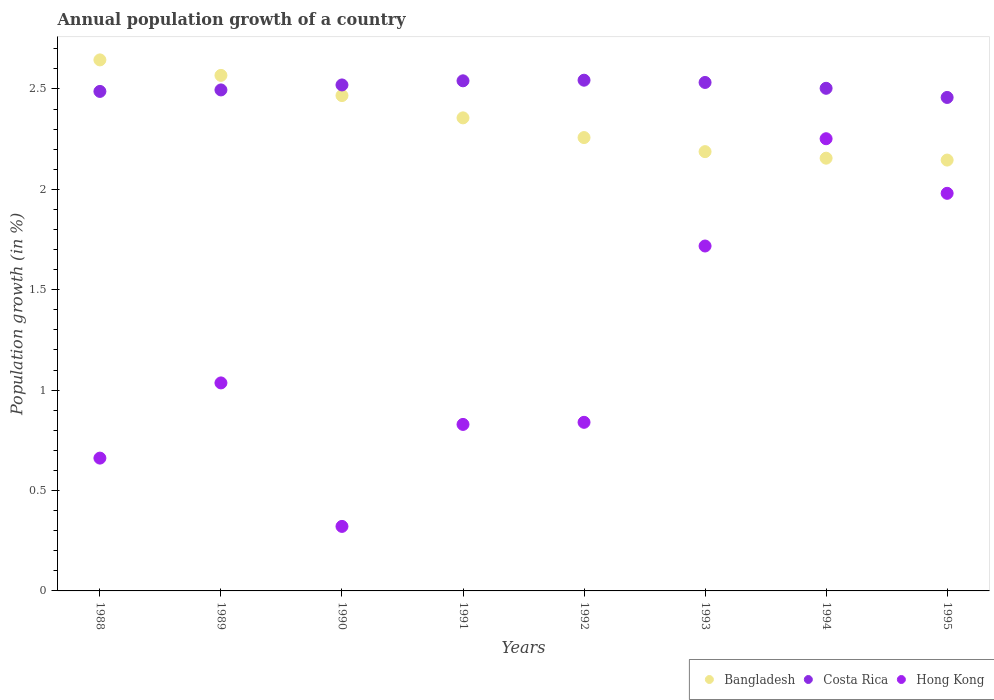How many different coloured dotlines are there?
Make the answer very short. 3. What is the annual population growth in Hong Kong in 1990?
Your answer should be very brief. 0.32. Across all years, what is the maximum annual population growth in Bangladesh?
Provide a succinct answer. 2.64. Across all years, what is the minimum annual population growth in Costa Rica?
Offer a very short reply. 2.46. In which year was the annual population growth in Bangladesh maximum?
Provide a succinct answer. 1988. What is the total annual population growth in Costa Rica in the graph?
Your answer should be very brief. 20.08. What is the difference between the annual population growth in Bangladesh in 1990 and that in 1992?
Your answer should be compact. 0.21. What is the difference between the annual population growth in Hong Kong in 1993 and the annual population growth in Costa Rica in 1995?
Offer a terse response. -0.74. What is the average annual population growth in Bangladesh per year?
Keep it short and to the point. 2.35. In the year 1988, what is the difference between the annual population growth in Hong Kong and annual population growth in Costa Rica?
Offer a terse response. -1.83. What is the ratio of the annual population growth in Bangladesh in 1988 to that in 1990?
Give a very brief answer. 1.07. Is the annual population growth in Hong Kong in 1990 less than that in 1993?
Provide a short and direct response. Yes. Is the difference between the annual population growth in Hong Kong in 1992 and 1995 greater than the difference between the annual population growth in Costa Rica in 1992 and 1995?
Your answer should be compact. No. What is the difference between the highest and the second highest annual population growth in Bangladesh?
Keep it short and to the point. 0.08. What is the difference between the highest and the lowest annual population growth in Hong Kong?
Provide a succinct answer. 1.93. In how many years, is the annual population growth in Bangladesh greater than the average annual population growth in Bangladesh taken over all years?
Offer a very short reply. 4. Is it the case that in every year, the sum of the annual population growth in Costa Rica and annual population growth in Bangladesh  is greater than the annual population growth in Hong Kong?
Your answer should be very brief. Yes. Is the annual population growth in Hong Kong strictly less than the annual population growth in Costa Rica over the years?
Your response must be concise. Yes. How many years are there in the graph?
Offer a terse response. 8. Does the graph contain any zero values?
Your answer should be compact. No. Does the graph contain grids?
Your answer should be very brief. No. Where does the legend appear in the graph?
Your answer should be compact. Bottom right. What is the title of the graph?
Ensure brevity in your answer.  Annual population growth of a country. What is the label or title of the X-axis?
Your answer should be compact. Years. What is the label or title of the Y-axis?
Offer a very short reply. Population growth (in %). What is the Population growth (in %) in Bangladesh in 1988?
Your answer should be very brief. 2.64. What is the Population growth (in %) in Costa Rica in 1988?
Offer a terse response. 2.49. What is the Population growth (in %) of Hong Kong in 1988?
Provide a short and direct response. 0.66. What is the Population growth (in %) of Bangladesh in 1989?
Give a very brief answer. 2.57. What is the Population growth (in %) of Costa Rica in 1989?
Provide a short and direct response. 2.5. What is the Population growth (in %) of Hong Kong in 1989?
Make the answer very short. 1.04. What is the Population growth (in %) in Bangladesh in 1990?
Make the answer very short. 2.47. What is the Population growth (in %) of Costa Rica in 1990?
Offer a very short reply. 2.52. What is the Population growth (in %) of Hong Kong in 1990?
Provide a short and direct response. 0.32. What is the Population growth (in %) of Bangladesh in 1991?
Provide a succinct answer. 2.36. What is the Population growth (in %) of Costa Rica in 1991?
Keep it short and to the point. 2.54. What is the Population growth (in %) in Hong Kong in 1991?
Offer a very short reply. 0.83. What is the Population growth (in %) of Bangladesh in 1992?
Ensure brevity in your answer.  2.26. What is the Population growth (in %) in Costa Rica in 1992?
Offer a very short reply. 2.54. What is the Population growth (in %) of Hong Kong in 1992?
Make the answer very short. 0.84. What is the Population growth (in %) in Bangladesh in 1993?
Provide a short and direct response. 2.19. What is the Population growth (in %) of Costa Rica in 1993?
Offer a very short reply. 2.53. What is the Population growth (in %) in Hong Kong in 1993?
Your answer should be very brief. 1.72. What is the Population growth (in %) in Bangladesh in 1994?
Provide a succinct answer. 2.16. What is the Population growth (in %) in Costa Rica in 1994?
Ensure brevity in your answer.  2.5. What is the Population growth (in %) of Hong Kong in 1994?
Give a very brief answer. 2.25. What is the Population growth (in %) in Bangladesh in 1995?
Offer a very short reply. 2.15. What is the Population growth (in %) in Costa Rica in 1995?
Give a very brief answer. 2.46. What is the Population growth (in %) of Hong Kong in 1995?
Offer a terse response. 1.98. Across all years, what is the maximum Population growth (in %) of Bangladesh?
Your response must be concise. 2.64. Across all years, what is the maximum Population growth (in %) of Costa Rica?
Provide a short and direct response. 2.54. Across all years, what is the maximum Population growth (in %) of Hong Kong?
Make the answer very short. 2.25. Across all years, what is the minimum Population growth (in %) of Bangladesh?
Provide a succinct answer. 2.15. Across all years, what is the minimum Population growth (in %) of Costa Rica?
Provide a succinct answer. 2.46. Across all years, what is the minimum Population growth (in %) of Hong Kong?
Give a very brief answer. 0.32. What is the total Population growth (in %) in Bangladesh in the graph?
Your answer should be very brief. 18.78. What is the total Population growth (in %) in Costa Rica in the graph?
Make the answer very short. 20.08. What is the total Population growth (in %) in Hong Kong in the graph?
Your response must be concise. 9.64. What is the difference between the Population growth (in %) in Bangladesh in 1988 and that in 1989?
Offer a terse response. 0.08. What is the difference between the Population growth (in %) of Costa Rica in 1988 and that in 1989?
Give a very brief answer. -0.01. What is the difference between the Population growth (in %) in Hong Kong in 1988 and that in 1989?
Make the answer very short. -0.37. What is the difference between the Population growth (in %) of Bangladesh in 1988 and that in 1990?
Your answer should be compact. 0.18. What is the difference between the Population growth (in %) of Costa Rica in 1988 and that in 1990?
Provide a short and direct response. -0.03. What is the difference between the Population growth (in %) in Hong Kong in 1988 and that in 1990?
Provide a short and direct response. 0.34. What is the difference between the Population growth (in %) of Bangladesh in 1988 and that in 1991?
Offer a very short reply. 0.29. What is the difference between the Population growth (in %) in Costa Rica in 1988 and that in 1991?
Provide a succinct answer. -0.05. What is the difference between the Population growth (in %) in Hong Kong in 1988 and that in 1991?
Ensure brevity in your answer.  -0.17. What is the difference between the Population growth (in %) in Bangladesh in 1988 and that in 1992?
Provide a succinct answer. 0.39. What is the difference between the Population growth (in %) in Costa Rica in 1988 and that in 1992?
Offer a terse response. -0.06. What is the difference between the Population growth (in %) of Hong Kong in 1988 and that in 1992?
Provide a succinct answer. -0.18. What is the difference between the Population growth (in %) in Bangladesh in 1988 and that in 1993?
Your response must be concise. 0.46. What is the difference between the Population growth (in %) in Costa Rica in 1988 and that in 1993?
Make the answer very short. -0.04. What is the difference between the Population growth (in %) of Hong Kong in 1988 and that in 1993?
Give a very brief answer. -1.06. What is the difference between the Population growth (in %) in Bangladesh in 1988 and that in 1994?
Provide a short and direct response. 0.49. What is the difference between the Population growth (in %) of Costa Rica in 1988 and that in 1994?
Offer a very short reply. -0.02. What is the difference between the Population growth (in %) in Hong Kong in 1988 and that in 1994?
Keep it short and to the point. -1.59. What is the difference between the Population growth (in %) of Bangladesh in 1988 and that in 1995?
Provide a succinct answer. 0.5. What is the difference between the Population growth (in %) of Costa Rica in 1988 and that in 1995?
Keep it short and to the point. 0.03. What is the difference between the Population growth (in %) in Hong Kong in 1988 and that in 1995?
Your answer should be compact. -1.32. What is the difference between the Population growth (in %) of Bangladesh in 1989 and that in 1990?
Offer a terse response. 0.1. What is the difference between the Population growth (in %) of Costa Rica in 1989 and that in 1990?
Provide a succinct answer. -0.02. What is the difference between the Population growth (in %) in Hong Kong in 1989 and that in 1990?
Your answer should be very brief. 0.71. What is the difference between the Population growth (in %) of Bangladesh in 1989 and that in 1991?
Provide a short and direct response. 0.21. What is the difference between the Population growth (in %) of Costa Rica in 1989 and that in 1991?
Offer a very short reply. -0.05. What is the difference between the Population growth (in %) in Hong Kong in 1989 and that in 1991?
Your response must be concise. 0.21. What is the difference between the Population growth (in %) of Bangladesh in 1989 and that in 1992?
Keep it short and to the point. 0.31. What is the difference between the Population growth (in %) of Costa Rica in 1989 and that in 1992?
Ensure brevity in your answer.  -0.05. What is the difference between the Population growth (in %) in Hong Kong in 1989 and that in 1992?
Your response must be concise. 0.2. What is the difference between the Population growth (in %) in Bangladesh in 1989 and that in 1993?
Ensure brevity in your answer.  0.38. What is the difference between the Population growth (in %) in Costa Rica in 1989 and that in 1993?
Provide a short and direct response. -0.04. What is the difference between the Population growth (in %) of Hong Kong in 1989 and that in 1993?
Ensure brevity in your answer.  -0.68. What is the difference between the Population growth (in %) of Bangladesh in 1989 and that in 1994?
Ensure brevity in your answer.  0.41. What is the difference between the Population growth (in %) of Costa Rica in 1989 and that in 1994?
Your response must be concise. -0.01. What is the difference between the Population growth (in %) of Hong Kong in 1989 and that in 1994?
Offer a very short reply. -1.22. What is the difference between the Population growth (in %) in Bangladesh in 1989 and that in 1995?
Give a very brief answer. 0.42. What is the difference between the Population growth (in %) in Costa Rica in 1989 and that in 1995?
Offer a very short reply. 0.04. What is the difference between the Population growth (in %) of Hong Kong in 1989 and that in 1995?
Offer a terse response. -0.94. What is the difference between the Population growth (in %) of Bangladesh in 1990 and that in 1991?
Ensure brevity in your answer.  0.11. What is the difference between the Population growth (in %) in Costa Rica in 1990 and that in 1991?
Keep it short and to the point. -0.02. What is the difference between the Population growth (in %) in Hong Kong in 1990 and that in 1991?
Make the answer very short. -0.51. What is the difference between the Population growth (in %) in Bangladesh in 1990 and that in 1992?
Ensure brevity in your answer.  0.21. What is the difference between the Population growth (in %) of Costa Rica in 1990 and that in 1992?
Keep it short and to the point. -0.02. What is the difference between the Population growth (in %) of Hong Kong in 1990 and that in 1992?
Ensure brevity in your answer.  -0.52. What is the difference between the Population growth (in %) of Bangladesh in 1990 and that in 1993?
Offer a terse response. 0.28. What is the difference between the Population growth (in %) in Costa Rica in 1990 and that in 1993?
Offer a terse response. -0.01. What is the difference between the Population growth (in %) in Hong Kong in 1990 and that in 1993?
Offer a terse response. -1.4. What is the difference between the Population growth (in %) in Bangladesh in 1990 and that in 1994?
Provide a succinct answer. 0.31. What is the difference between the Population growth (in %) in Costa Rica in 1990 and that in 1994?
Your answer should be compact. 0.02. What is the difference between the Population growth (in %) of Hong Kong in 1990 and that in 1994?
Your answer should be very brief. -1.93. What is the difference between the Population growth (in %) in Bangladesh in 1990 and that in 1995?
Offer a terse response. 0.32. What is the difference between the Population growth (in %) of Costa Rica in 1990 and that in 1995?
Offer a very short reply. 0.06. What is the difference between the Population growth (in %) of Hong Kong in 1990 and that in 1995?
Give a very brief answer. -1.66. What is the difference between the Population growth (in %) of Bangladesh in 1991 and that in 1992?
Keep it short and to the point. 0.1. What is the difference between the Population growth (in %) of Costa Rica in 1991 and that in 1992?
Offer a terse response. -0. What is the difference between the Population growth (in %) in Hong Kong in 1991 and that in 1992?
Offer a very short reply. -0.01. What is the difference between the Population growth (in %) in Bangladesh in 1991 and that in 1993?
Offer a terse response. 0.17. What is the difference between the Population growth (in %) of Costa Rica in 1991 and that in 1993?
Make the answer very short. 0.01. What is the difference between the Population growth (in %) of Hong Kong in 1991 and that in 1993?
Keep it short and to the point. -0.89. What is the difference between the Population growth (in %) of Bangladesh in 1991 and that in 1994?
Keep it short and to the point. 0.2. What is the difference between the Population growth (in %) in Costa Rica in 1991 and that in 1994?
Your response must be concise. 0.04. What is the difference between the Population growth (in %) in Hong Kong in 1991 and that in 1994?
Ensure brevity in your answer.  -1.42. What is the difference between the Population growth (in %) in Bangladesh in 1991 and that in 1995?
Provide a succinct answer. 0.21. What is the difference between the Population growth (in %) of Costa Rica in 1991 and that in 1995?
Your answer should be compact. 0.08. What is the difference between the Population growth (in %) of Hong Kong in 1991 and that in 1995?
Offer a terse response. -1.15. What is the difference between the Population growth (in %) of Bangladesh in 1992 and that in 1993?
Make the answer very short. 0.07. What is the difference between the Population growth (in %) in Costa Rica in 1992 and that in 1993?
Offer a terse response. 0.01. What is the difference between the Population growth (in %) in Hong Kong in 1992 and that in 1993?
Your response must be concise. -0.88. What is the difference between the Population growth (in %) of Bangladesh in 1992 and that in 1994?
Ensure brevity in your answer.  0.1. What is the difference between the Population growth (in %) of Costa Rica in 1992 and that in 1994?
Offer a terse response. 0.04. What is the difference between the Population growth (in %) in Hong Kong in 1992 and that in 1994?
Provide a short and direct response. -1.41. What is the difference between the Population growth (in %) of Bangladesh in 1992 and that in 1995?
Offer a terse response. 0.11. What is the difference between the Population growth (in %) of Costa Rica in 1992 and that in 1995?
Your answer should be very brief. 0.09. What is the difference between the Population growth (in %) in Hong Kong in 1992 and that in 1995?
Your answer should be very brief. -1.14. What is the difference between the Population growth (in %) in Bangladesh in 1993 and that in 1994?
Offer a terse response. 0.03. What is the difference between the Population growth (in %) in Costa Rica in 1993 and that in 1994?
Provide a short and direct response. 0.03. What is the difference between the Population growth (in %) of Hong Kong in 1993 and that in 1994?
Provide a short and direct response. -0.53. What is the difference between the Population growth (in %) in Bangladesh in 1993 and that in 1995?
Ensure brevity in your answer.  0.04. What is the difference between the Population growth (in %) in Costa Rica in 1993 and that in 1995?
Give a very brief answer. 0.07. What is the difference between the Population growth (in %) of Hong Kong in 1993 and that in 1995?
Your answer should be compact. -0.26. What is the difference between the Population growth (in %) of Bangladesh in 1994 and that in 1995?
Your response must be concise. 0.01. What is the difference between the Population growth (in %) in Costa Rica in 1994 and that in 1995?
Offer a terse response. 0.05. What is the difference between the Population growth (in %) in Hong Kong in 1994 and that in 1995?
Your answer should be compact. 0.27. What is the difference between the Population growth (in %) of Bangladesh in 1988 and the Population growth (in %) of Costa Rica in 1989?
Provide a succinct answer. 0.15. What is the difference between the Population growth (in %) in Bangladesh in 1988 and the Population growth (in %) in Hong Kong in 1989?
Provide a succinct answer. 1.61. What is the difference between the Population growth (in %) in Costa Rica in 1988 and the Population growth (in %) in Hong Kong in 1989?
Offer a very short reply. 1.45. What is the difference between the Population growth (in %) of Bangladesh in 1988 and the Population growth (in %) of Costa Rica in 1990?
Give a very brief answer. 0.12. What is the difference between the Population growth (in %) of Bangladesh in 1988 and the Population growth (in %) of Hong Kong in 1990?
Ensure brevity in your answer.  2.32. What is the difference between the Population growth (in %) of Costa Rica in 1988 and the Population growth (in %) of Hong Kong in 1990?
Offer a very short reply. 2.17. What is the difference between the Population growth (in %) in Bangladesh in 1988 and the Population growth (in %) in Costa Rica in 1991?
Offer a very short reply. 0.1. What is the difference between the Population growth (in %) of Bangladesh in 1988 and the Population growth (in %) of Hong Kong in 1991?
Ensure brevity in your answer.  1.82. What is the difference between the Population growth (in %) in Costa Rica in 1988 and the Population growth (in %) in Hong Kong in 1991?
Make the answer very short. 1.66. What is the difference between the Population growth (in %) in Bangladesh in 1988 and the Population growth (in %) in Costa Rica in 1992?
Make the answer very short. 0.1. What is the difference between the Population growth (in %) of Bangladesh in 1988 and the Population growth (in %) of Hong Kong in 1992?
Offer a terse response. 1.8. What is the difference between the Population growth (in %) of Costa Rica in 1988 and the Population growth (in %) of Hong Kong in 1992?
Keep it short and to the point. 1.65. What is the difference between the Population growth (in %) of Bangladesh in 1988 and the Population growth (in %) of Costa Rica in 1993?
Keep it short and to the point. 0.11. What is the difference between the Population growth (in %) of Bangladesh in 1988 and the Population growth (in %) of Hong Kong in 1993?
Make the answer very short. 0.93. What is the difference between the Population growth (in %) of Costa Rica in 1988 and the Population growth (in %) of Hong Kong in 1993?
Keep it short and to the point. 0.77. What is the difference between the Population growth (in %) of Bangladesh in 1988 and the Population growth (in %) of Costa Rica in 1994?
Give a very brief answer. 0.14. What is the difference between the Population growth (in %) of Bangladesh in 1988 and the Population growth (in %) of Hong Kong in 1994?
Provide a short and direct response. 0.39. What is the difference between the Population growth (in %) of Costa Rica in 1988 and the Population growth (in %) of Hong Kong in 1994?
Make the answer very short. 0.24. What is the difference between the Population growth (in %) of Bangladesh in 1988 and the Population growth (in %) of Costa Rica in 1995?
Offer a very short reply. 0.19. What is the difference between the Population growth (in %) in Bangladesh in 1988 and the Population growth (in %) in Hong Kong in 1995?
Keep it short and to the point. 0.66. What is the difference between the Population growth (in %) of Costa Rica in 1988 and the Population growth (in %) of Hong Kong in 1995?
Provide a short and direct response. 0.51. What is the difference between the Population growth (in %) in Bangladesh in 1989 and the Population growth (in %) in Costa Rica in 1990?
Give a very brief answer. 0.05. What is the difference between the Population growth (in %) in Bangladesh in 1989 and the Population growth (in %) in Hong Kong in 1990?
Provide a short and direct response. 2.25. What is the difference between the Population growth (in %) in Costa Rica in 1989 and the Population growth (in %) in Hong Kong in 1990?
Offer a terse response. 2.17. What is the difference between the Population growth (in %) of Bangladesh in 1989 and the Population growth (in %) of Costa Rica in 1991?
Your response must be concise. 0.03. What is the difference between the Population growth (in %) of Bangladesh in 1989 and the Population growth (in %) of Hong Kong in 1991?
Give a very brief answer. 1.74. What is the difference between the Population growth (in %) in Costa Rica in 1989 and the Population growth (in %) in Hong Kong in 1991?
Offer a terse response. 1.67. What is the difference between the Population growth (in %) of Bangladesh in 1989 and the Population growth (in %) of Costa Rica in 1992?
Provide a succinct answer. 0.02. What is the difference between the Population growth (in %) of Bangladesh in 1989 and the Population growth (in %) of Hong Kong in 1992?
Offer a very short reply. 1.73. What is the difference between the Population growth (in %) in Costa Rica in 1989 and the Population growth (in %) in Hong Kong in 1992?
Keep it short and to the point. 1.66. What is the difference between the Population growth (in %) of Bangladesh in 1989 and the Population growth (in %) of Costa Rica in 1993?
Your answer should be very brief. 0.04. What is the difference between the Population growth (in %) in Bangladesh in 1989 and the Population growth (in %) in Hong Kong in 1993?
Offer a very short reply. 0.85. What is the difference between the Population growth (in %) of Costa Rica in 1989 and the Population growth (in %) of Hong Kong in 1993?
Provide a succinct answer. 0.78. What is the difference between the Population growth (in %) in Bangladesh in 1989 and the Population growth (in %) in Costa Rica in 1994?
Offer a terse response. 0.06. What is the difference between the Population growth (in %) in Bangladesh in 1989 and the Population growth (in %) in Hong Kong in 1994?
Provide a short and direct response. 0.32. What is the difference between the Population growth (in %) of Costa Rica in 1989 and the Population growth (in %) of Hong Kong in 1994?
Keep it short and to the point. 0.24. What is the difference between the Population growth (in %) of Bangladesh in 1989 and the Population growth (in %) of Costa Rica in 1995?
Provide a succinct answer. 0.11. What is the difference between the Population growth (in %) of Bangladesh in 1989 and the Population growth (in %) of Hong Kong in 1995?
Your response must be concise. 0.59. What is the difference between the Population growth (in %) in Costa Rica in 1989 and the Population growth (in %) in Hong Kong in 1995?
Give a very brief answer. 0.51. What is the difference between the Population growth (in %) in Bangladesh in 1990 and the Population growth (in %) in Costa Rica in 1991?
Offer a very short reply. -0.07. What is the difference between the Population growth (in %) in Bangladesh in 1990 and the Population growth (in %) in Hong Kong in 1991?
Make the answer very short. 1.64. What is the difference between the Population growth (in %) in Costa Rica in 1990 and the Population growth (in %) in Hong Kong in 1991?
Provide a succinct answer. 1.69. What is the difference between the Population growth (in %) in Bangladesh in 1990 and the Population growth (in %) in Costa Rica in 1992?
Your answer should be very brief. -0.08. What is the difference between the Population growth (in %) in Bangladesh in 1990 and the Population growth (in %) in Hong Kong in 1992?
Offer a terse response. 1.63. What is the difference between the Population growth (in %) in Costa Rica in 1990 and the Population growth (in %) in Hong Kong in 1992?
Your response must be concise. 1.68. What is the difference between the Population growth (in %) in Bangladesh in 1990 and the Population growth (in %) in Costa Rica in 1993?
Give a very brief answer. -0.07. What is the difference between the Population growth (in %) in Bangladesh in 1990 and the Population growth (in %) in Hong Kong in 1993?
Your response must be concise. 0.75. What is the difference between the Population growth (in %) of Costa Rica in 1990 and the Population growth (in %) of Hong Kong in 1993?
Make the answer very short. 0.8. What is the difference between the Population growth (in %) in Bangladesh in 1990 and the Population growth (in %) in Costa Rica in 1994?
Your response must be concise. -0.04. What is the difference between the Population growth (in %) of Bangladesh in 1990 and the Population growth (in %) of Hong Kong in 1994?
Ensure brevity in your answer.  0.21. What is the difference between the Population growth (in %) in Costa Rica in 1990 and the Population growth (in %) in Hong Kong in 1994?
Your answer should be very brief. 0.27. What is the difference between the Population growth (in %) of Bangladesh in 1990 and the Population growth (in %) of Costa Rica in 1995?
Offer a very short reply. 0.01. What is the difference between the Population growth (in %) in Bangladesh in 1990 and the Population growth (in %) in Hong Kong in 1995?
Provide a succinct answer. 0.49. What is the difference between the Population growth (in %) in Costa Rica in 1990 and the Population growth (in %) in Hong Kong in 1995?
Ensure brevity in your answer.  0.54. What is the difference between the Population growth (in %) of Bangladesh in 1991 and the Population growth (in %) of Costa Rica in 1992?
Your response must be concise. -0.19. What is the difference between the Population growth (in %) of Bangladesh in 1991 and the Population growth (in %) of Hong Kong in 1992?
Offer a terse response. 1.52. What is the difference between the Population growth (in %) in Costa Rica in 1991 and the Population growth (in %) in Hong Kong in 1992?
Your answer should be very brief. 1.7. What is the difference between the Population growth (in %) of Bangladesh in 1991 and the Population growth (in %) of Costa Rica in 1993?
Give a very brief answer. -0.18. What is the difference between the Population growth (in %) in Bangladesh in 1991 and the Population growth (in %) in Hong Kong in 1993?
Provide a succinct answer. 0.64. What is the difference between the Population growth (in %) of Costa Rica in 1991 and the Population growth (in %) of Hong Kong in 1993?
Provide a succinct answer. 0.82. What is the difference between the Population growth (in %) of Bangladesh in 1991 and the Population growth (in %) of Costa Rica in 1994?
Ensure brevity in your answer.  -0.15. What is the difference between the Population growth (in %) of Bangladesh in 1991 and the Population growth (in %) of Hong Kong in 1994?
Offer a terse response. 0.1. What is the difference between the Population growth (in %) of Costa Rica in 1991 and the Population growth (in %) of Hong Kong in 1994?
Make the answer very short. 0.29. What is the difference between the Population growth (in %) of Bangladesh in 1991 and the Population growth (in %) of Costa Rica in 1995?
Keep it short and to the point. -0.1. What is the difference between the Population growth (in %) of Bangladesh in 1991 and the Population growth (in %) of Hong Kong in 1995?
Provide a short and direct response. 0.38. What is the difference between the Population growth (in %) in Costa Rica in 1991 and the Population growth (in %) in Hong Kong in 1995?
Provide a short and direct response. 0.56. What is the difference between the Population growth (in %) in Bangladesh in 1992 and the Population growth (in %) in Costa Rica in 1993?
Keep it short and to the point. -0.27. What is the difference between the Population growth (in %) in Bangladesh in 1992 and the Population growth (in %) in Hong Kong in 1993?
Ensure brevity in your answer.  0.54. What is the difference between the Population growth (in %) in Costa Rica in 1992 and the Population growth (in %) in Hong Kong in 1993?
Provide a succinct answer. 0.83. What is the difference between the Population growth (in %) in Bangladesh in 1992 and the Population growth (in %) in Costa Rica in 1994?
Keep it short and to the point. -0.25. What is the difference between the Population growth (in %) of Bangladesh in 1992 and the Population growth (in %) of Hong Kong in 1994?
Provide a short and direct response. 0.01. What is the difference between the Population growth (in %) of Costa Rica in 1992 and the Population growth (in %) of Hong Kong in 1994?
Offer a terse response. 0.29. What is the difference between the Population growth (in %) in Bangladesh in 1992 and the Population growth (in %) in Costa Rica in 1995?
Ensure brevity in your answer.  -0.2. What is the difference between the Population growth (in %) of Bangladesh in 1992 and the Population growth (in %) of Hong Kong in 1995?
Your response must be concise. 0.28. What is the difference between the Population growth (in %) of Costa Rica in 1992 and the Population growth (in %) of Hong Kong in 1995?
Ensure brevity in your answer.  0.56. What is the difference between the Population growth (in %) in Bangladesh in 1993 and the Population growth (in %) in Costa Rica in 1994?
Offer a terse response. -0.32. What is the difference between the Population growth (in %) of Bangladesh in 1993 and the Population growth (in %) of Hong Kong in 1994?
Give a very brief answer. -0.06. What is the difference between the Population growth (in %) of Costa Rica in 1993 and the Population growth (in %) of Hong Kong in 1994?
Your response must be concise. 0.28. What is the difference between the Population growth (in %) in Bangladesh in 1993 and the Population growth (in %) in Costa Rica in 1995?
Provide a succinct answer. -0.27. What is the difference between the Population growth (in %) in Bangladesh in 1993 and the Population growth (in %) in Hong Kong in 1995?
Your response must be concise. 0.21. What is the difference between the Population growth (in %) of Costa Rica in 1993 and the Population growth (in %) of Hong Kong in 1995?
Your answer should be very brief. 0.55. What is the difference between the Population growth (in %) of Bangladesh in 1994 and the Population growth (in %) of Costa Rica in 1995?
Provide a succinct answer. -0.3. What is the difference between the Population growth (in %) of Bangladesh in 1994 and the Population growth (in %) of Hong Kong in 1995?
Offer a very short reply. 0.17. What is the difference between the Population growth (in %) in Costa Rica in 1994 and the Population growth (in %) in Hong Kong in 1995?
Ensure brevity in your answer.  0.52. What is the average Population growth (in %) in Bangladesh per year?
Offer a terse response. 2.35. What is the average Population growth (in %) in Costa Rica per year?
Offer a very short reply. 2.51. What is the average Population growth (in %) in Hong Kong per year?
Make the answer very short. 1.2. In the year 1988, what is the difference between the Population growth (in %) of Bangladesh and Population growth (in %) of Costa Rica?
Your answer should be compact. 0.16. In the year 1988, what is the difference between the Population growth (in %) in Bangladesh and Population growth (in %) in Hong Kong?
Offer a very short reply. 1.98. In the year 1988, what is the difference between the Population growth (in %) in Costa Rica and Population growth (in %) in Hong Kong?
Your answer should be very brief. 1.83. In the year 1989, what is the difference between the Population growth (in %) of Bangladesh and Population growth (in %) of Costa Rica?
Make the answer very short. 0.07. In the year 1989, what is the difference between the Population growth (in %) in Bangladesh and Population growth (in %) in Hong Kong?
Offer a very short reply. 1.53. In the year 1989, what is the difference between the Population growth (in %) in Costa Rica and Population growth (in %) in Hong Kong?
Offer a terse response. 1.46. In the year 1990, what is the difference between the Population growth (in %) of Bangladesh and Population growth (in %) of Costa Rica?
Give a very brief answer. -0.05. In the year 1990, what is the difference between the Population growth (in %) in Bangladesh and Population growth (in %) in Hong Kong?
Your answer should be very brief. 2.15. In the year 1990, what is the difference between the Population growth (in %) in Costa Rica and Population growth (in %) in Hong Kong?
Ensure brevity in your answer.  2.2. In the year 1991, what is the difference between the Population growth (in %) of Bangladesh and Population growth (in %) of Costa Rica?
Give a very brief answer. -0.18. In the year 1991, what is the difference between the Population growth (in %) in Bangladesh and Population growth (in %) in Hong Kong?
Your answer should be compact. 1.53. In the year 1991, what is the difference between the Population growth (in %) in Costa Rica and Population growth (in %) in Hong Kong?
Make the answer very short. 1.71. In the year 1992, what is the difference between the Population growth (in %) of Bangladesh and Population growth (in %) of Costa Rica?
Offer a terse response. -0.29. In the year 1992, what is the difference between the Population growth (in %) in Bangladesh and Population growth (in %) in Hong Kong?
Keep it short and to the point. 1.42. In the year 1992, what is the difference between the Population growth (in %) of Costa Rica and Population growth (in %) of Hong Kong?
Your answer should be very brief. 1.7. In the year 1993, what is the difference between the Population growth (in %) in Bangladesh and Population growth (in %) in Costa Rica?
Keep it short and to the point. -0.34. In the year 1993, what is the difference between the Population growth (in %) in Bangladesh and Population growth (in %) in Hong Kong?
Make the answer very short. 0.47. In the year 1993, what is the difference between the Population growth (in %) in Costa Rica and Population growth (in %) in Hong Kong?
Keep it short and to the point. 0.81. In the year 1994, what is the difference between the Population growth (in %) in Bangladesh and Population growth (in %) in Costa Rica?
Provide a short and direct response. -0.35. In the year 1994, what is the difference between the Population growth (in %) in Bangladesh and Population growth (in %) in Hong Kong?
Your response must be concise. -0.1. In the year 1994, what is the difference between the Population growth (in %) of Costa Rica and Population growth (in %) of Hong Kong?
Ensure brevity in your answer.  0.25. In the year 1995, what is the difference between the Population growth (in %) in Bangladesh and Population growth (in %) in Costa Rica?
Ensure brevity in your answer.  -0.31. In the year 1995, what is the difference between the Population growth (in %) in Bangladesh and Population growth (in %) in Hong Kong?
Your answer should be very brief. 0.17. In the year 1995, what is the difference between the Population growth (in %) of Costa Rica and Population growth (in %) of Hong Kong?
Make the answer very short. 0.48. What is the ratio of the Population growth (in %) of Costa Rica in 1988 to that in 1989?
Make the answer very short. 1. What is the ratio of the Population growth (in %) of Hong Kong in 1988 to that in 1989?
Provide a short and direct response. 0.64. What is the ratio of the Population growth (in %) in Bangladesh in 1988 to that in 1990?
Provide a short and direct response. 1.07. What is the ratio of the Population growth (in %) of Costa Rica in 1988 to that in 1990?
Your answer should be compact. 0.99. What is the ratio of the Population growth (in %) in Hong Kong in 1988 to that in 1990?
Make the answer very short. 2.06. What is the ratio of the Population growth (in %) of Bangladesh in 1988 to that in 1991?
Offer a very short reply. 1.12. What is the ratio of the Population growth (in %) of Costa Rica in 1988 to that in 1991?
Keep it short and to the point. 0.98. What is the ratio of the Population growth (in %) of Hong Kong in 1988 to that in 1991?
Keep it short and to the point. 0.8. What is the ratio of the Population growth (in %) of Bangladesh in 1988 to that in 1992?
Provide a short and direct response. 1.17. What is the ratio of the Population growth (in %) of Costa Rica in 1988 to that in 1992?
Offer a very short reply. 0.98. What is the ratio of the Population growth (in %) of Hong Kong in 1988 to that in 1992?
Give a very brief answer. 0.79. What is the ratio of the Population growth (in %) in Bangladesh in 1988 to that in 1993?
Offer a terse response. 1.21. What is the ratio of the Population growth (in %) in Costa Rica in 1988 to that in 1993?
Make the answer very short. 0.98. What is the ratio of the Population growth (in %) of Hong Kong in 1988 to that in 1993?
Make the answer very short. 0.39. What is the ratio of the Population growth (in %) in Bangladesh in 1988 to that in 1994?
Make the answer very short. 1.23. What is the ratio of the Population growth (in %) in Costa Rica in 1988 to that in 1994?
Provide a short and direct response. 0.99. What is the ratio of the Population growth (in %) in Hong Kong in 1988 to that in 1994?
Offer a terse response. 0.29. What is the ratio of the Population growth (in %) in Bangladesh in 1988 to that in 1995?
Ensure brevity in your answer.  1.23. What is the ratio of the Population growth (in %) of Costa Rica in 1988 to that in 1995?
Provide a succinct answer. 1.01. What is the ratio of the Population growth (in %) of Hong Kong in 1988 to that in 1995?
Your response must be concise. 0.33. What is the ratio of the Population growth (in %) in Bangladesh in 1989 to that in 1990?
Provide a succinct answer. 1.04. What is the ratio of the Population growth (in %) of Costa Rica in 1989 to that in 1990?
Offer a very short reply. 0.99. What is the ratio of the Population growth (in %) of Hong Kong in 1989 to that in 1990?
Your answer should be very brief. 3.22. What is the ratio of the Population growth (in %) of Bangladesh in 1989 to that in 1991?
Make the answer very short. 1.09. What is the ratio of the Population growth (in %) of Costa Rica in 1989 to that in 1991?
Provide a succinct answer. 0.98. What is the ratio of the Population growth (in %) of Hong Kong in 1989 to that in 1991?
Offer a very short reply. 1.25. What is the ratio of the Population growth (in %) in Bangladesh in 1989 to that in 1992?
Your answer should be very brief. 1.14. What is the ratio of the Population growth (in %) of Hong Kong in 1989 to that in 1992?
Your answer should be compact. 1.23. What is the ratio of the Population growth (in %) in Bangladesh in 1989 to that in 1993?
Offer a very short reply. 1.17. What is the ratio of the Population growth (in %) in Hong Kong in 1989 to that in 1993?
Provide a short and direct response. 0.6. What is the ratio of the Population growth (in %) of Bangladesh in 1989 to that in 1994?
Provide a succinct answer. 1.19. What is the ratio of the Population growth (in %) in Costa Rica in 1989 to that in 1994?
Your answer should be compact. 1. What is the ratio of the Population growth (in %) of Hong Kong in 1989 to that in 1994?
Give a very brief answer. 0.46. What is the ratio of the Population growth (in %) in Bangladesh in 1989 to that in 1995?
Provide a succinct answer. 1.2. What is the ratio of the Population growth (in %) in Costa Rica in 1989 to that in 1995?
Give a very brief answer. 1.02. What is the ratio of the Population growth (in %) in Hong Kong in 1989 to that in 1995?
Provide a short and direct response. 0.52. What is the ratio of the Population growth (in %) in Bangladesh in 1990 to that in 1991?
Offer a terse response. 1.05. What is the ratio of the Population growth (in %) in Hong Kong in 1990 to that in 1991?
Provide a succinct answer. 0.39. What is the ratio of the Population growth (in %) of Bangladesh in 1990 to that in 1992?
Offer a terse response. 1.09. What is the ratio of the Population growth (in %) in Costa Rica in 1990 to that in 1992?
Ensure brevity in your answer.  0.99. What is the ratio of the Population growth (in %) in Hong Kong in 1990 to that in 1992?
Make the answer very short. 0.38. What is the ratio of the Population growth (in %) in Bangladesh in 1990 to that in 1993?
Keep it short and to the point. 1.13. What is the ratio of the Population growth (in %) in Costa Rica in 1990 to that in 1993?
Offer a very short reply. 1. What is the ratio of the Population growth (in %) of Hong Kong in 1990 to that in 1993?
Provide a short and direct response. 0.19. What is the ratio of the Population growth (in %) in Bangladesh in 1990 to that in 1994?
Provide a succinct answer. 1.14. What is the ratio of the Population growth (in %) in Costa Rica in 1990 to that in 1994?
Provide a succinct answer. 1.01. What is the ratio of the Population growth (in %) of Hong Kong in 1990 to that in 1994?
Offer a very short reply. 0.14. What is the ratio of the Population growth (in %) in Bangladesh in 1990 to that in 1995?
Your answer should be compact. 1.15. What is the ratio of the Population growth (in %) of Costa Rica in 1990 to that in 1995?
Give a very brief answer. 1.03. What is the ratio of the Population growth (in %) of Hong Kong in 1990 to that in 1995?
Your answer should be very brief. 0.16. What is the ratio of the Population growth (in %) of Bangladesh in 1991 to that in 1992?
Your answer should be very brief. 1.04. What is the ratio of the Population growth (in %) in Hong Kong in 1991 to that in 1992?
Give a very brief answer. 0.99. What is the ratio of the Population growth (in %) in Hong Kong in 1991 to that in 1993?
Provide a succinct answer. 0.48. What is the ratio of the Population growth (in %) of Bangladesh in 1991 to that in 1994?
Give a very brief answer. 1.09. What is the ratio of the Population growth (in %) in Costa Rica in 1991 to that in 1994?
Keep it short and to the point. 1.01. What is the ratio of the Population growth (in %) in Hong Kong in 1991 to that in 1994?
Offer a very short reply. 0.37. What is the ratio of the Population growth (in %) in Bangladesh in 1991 to that in 1995?
Provide a succinct answer. 1.1. What is the ratio of the Population growth (in %) in Costa Rica in 1991 to that in 1995?
Give a very brief answer. 1.03. What is the ratio of the Population growth (in %) in Hong Kong in 1991 to that in 1995?
Offer a terse response. 0.42. What is the ratio of the Population growth (in %) in Bangladesh in 1992 to that in 1993?
Provide a succinct answer. 1.03. What is the ratio of the Population growth (in %) of Hong Kong in 1992 to that in 1993?
Give a very brief answer. 0.49. What is the ratio of the Population growth (in %) in Bangladesh in 1992 to that in 1994?
Offer a terse response. 1.05. What is the ratio of the Population growth (in %) of Costa Rica in 1992 to that in 1994?
Ensure brevity in your answer.  1.02. What is the ratio of the Population growth (in %) of Hong Kong in 1992 to that in 1994?
Offer a very short reply. 0.37. What is the ratio of the Population growth (in %) in Bangladesh in 1992 to that in 1995?
Keep it short and to the point. 1.05. What is the ratio of the Population growth (in %) in Costa Rica in 1992 to that in 1995?
Give a very brief answer. 1.03. What is the ratio of the Population growth (in %) of Hong Kong in 1992 to that in 1995?
Offer a very short reply. 0.42. What is the ratio of the Population growth (in %) of Bangladesh in 1993 to that in 1994?
Offer a terse response. 1.02. What is the ratio of the Population growth (in %) in Costa Rica in 1993 to that in 1994?
Keep it short and to the point. 1.01. What is the ratio of the Population growth (in %) of Hong Kong in 1993 to that in 1994?
Give a very brief answer. 0.76. What is the ratio of the Population growth (in %) of Bangladesh in 1993 to that in 1995?
Give a very brief answer. 1.02. What is the ratio of the Population growth (in %) of Costa Rica in 1993 to that in 1995?
Keep it short and to the point. 1.03. What is the ratio of the Population growth (in %) of Hong Kong in 1993 to that in 1995?
Provide a succinct answer. 0.87. What is the ratio of the Population growth (in %) of Costa Rica in 1994 to that in 1995?
Offer a terse response. 1.02. What is the ratio of the Population growth (in %) of Hong Kong in 1994 to that in 1995?
Make the answer very short. 1.14. What is the difference between the highest and the second highest Population growth (in %) in Bangladesh?
Make the answer very short. 0.08. What is the difference between the highest and the second highest Population growth (in %) in Costa Rica?
Your response must be concise. 0. What is the difference between the highest and the second highest Population growth (in %) of Hong Kong?
Provide a short and direct response. 0.27. What is the difference between the highest and the lowest Population growth (in %) of Bangladesh?
Your response must be concise. 0.5. What is the difference between the highest and the lowest Population growth (in %) of Costa Rica?
Your response must be concise. 0.09. What is the difference between the highest and the lowest Population growth (in %) in Hong Kong?
Provide a short and direct response. 1.93. 